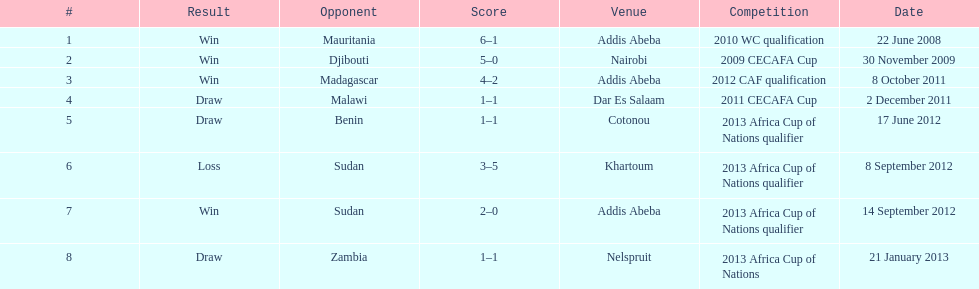Number of different teams listed on the chart 7. 